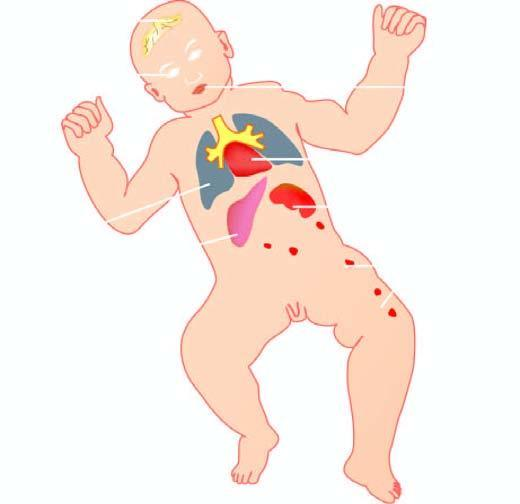s esions produced by torch complex infection in foetus in utero?
Answer the question using a single word or phrase. Yes 